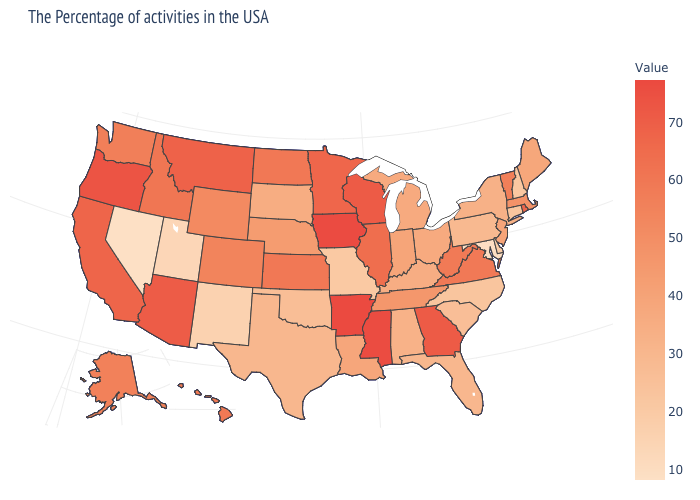Among the states that border Virginia , which have the highest value?
Quick response, please. West Virginia. Does New Hampshire have the lowest value in the Northeast?
Give a very brief answer. Yes. Does South Carolina have the lowest value in the USA?
Keep it brief. No. Among the states that border Connecticut , does Massachusetts have the highest value?
Be succinct. No. Among the states that border Wisconsin , does Iowa have the highest value?
Quick response, please. Yes. Among the states that border Utah , does Colorado have the lowest value?
Give a very brief answer. No. Does Nevada have the lowest value in the USA?
Concise answer only. Yes. 